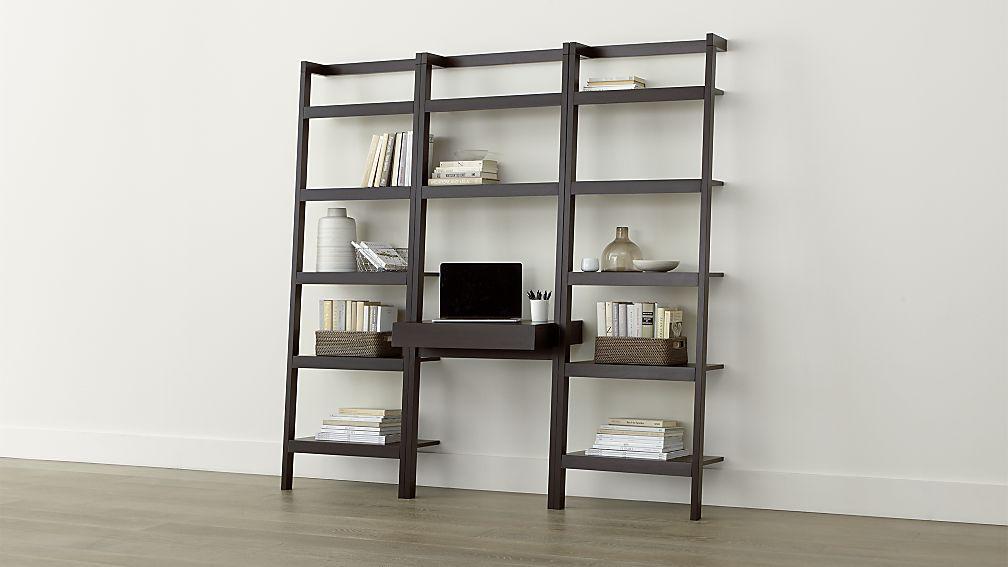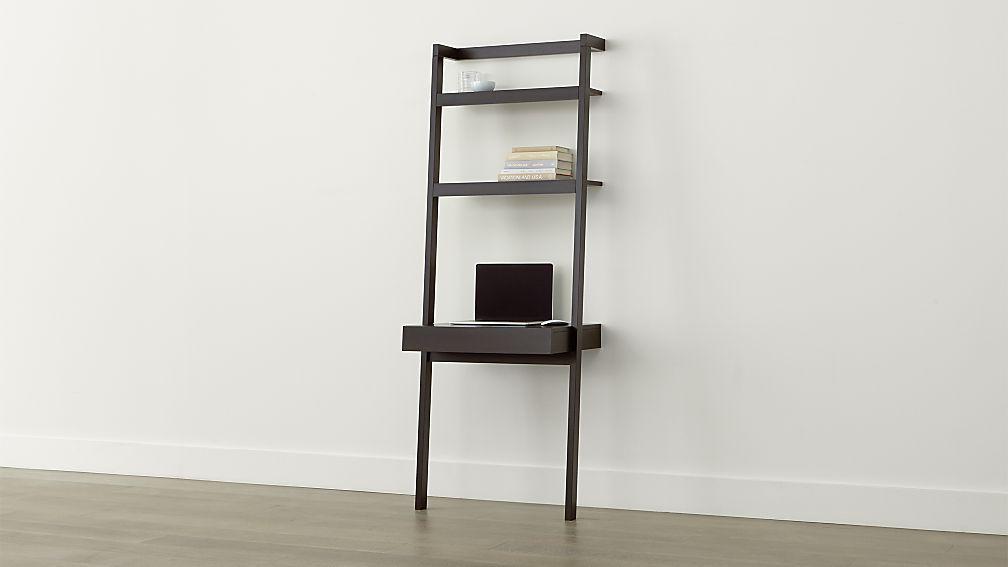The first image is the image on the left, the second image is the image on the right. Evaluate the accuracy of this statement regarding the images: "One shelf has 3 columns, while the other one has only one.". Is it true? Answer yes or no. Yes. 